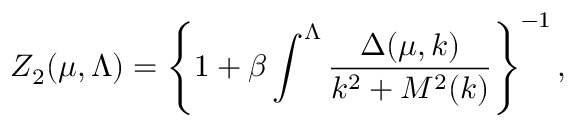<formula> <loc_0><loc_0><loc_500><loc_500>Z _ { 2 } ( \mu , \Lambda ) = \left \{ 1 + \beta \int ^ { \Lambda } \frac { \Delta ( \mu , k ) } { k ^ { 2 } + M ^ { 2 } ( k ) } \right \} ^ { - 1 } ,</formula> 